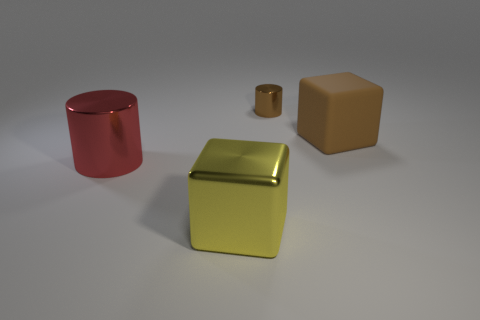Add 4 purple matte cylinders. How many objects exist? 8 Add 1 large matte objects. How many large matte objects exist? 2 Subtract 0 red spheres. How many objects are left? 4 Subtract all big cylinders. Subtract all red cylinders. How many objects are left? 2 Add 2 small brown cylinders. How many small brown cylinders are left? 3 